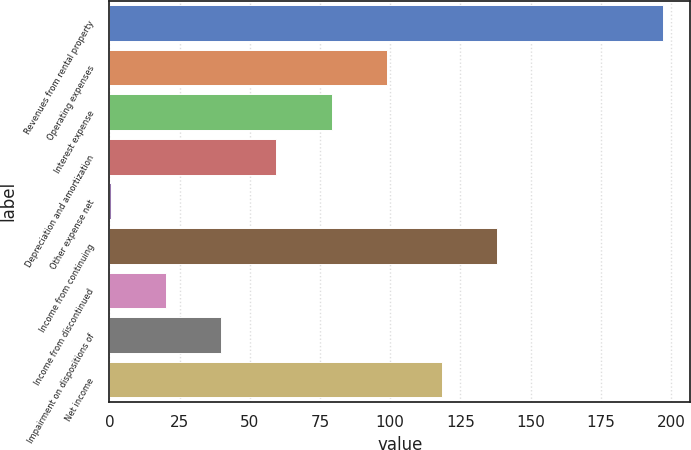Convert chart to OTSL. <chart><loc_0><loc_0><loc_500><loc_500><bar_chart><fcel>Revenues from rental property<fcel>Operating expenses<fcel>Interest expense<fcel>Depreciation and amortization<fcel>Other expense net<fcel>Income from continuing<fcel>Income from discontinued<fcel>Impairment on dispositions of<fcel>Net income<nl><fcel>197<fcel>98.8<fcel>79.16<fcel>59.52<fcel>0.6<fcel>138.08<fcel>20.24<fcel>39.88<fcel>118.44<nl></chart> 